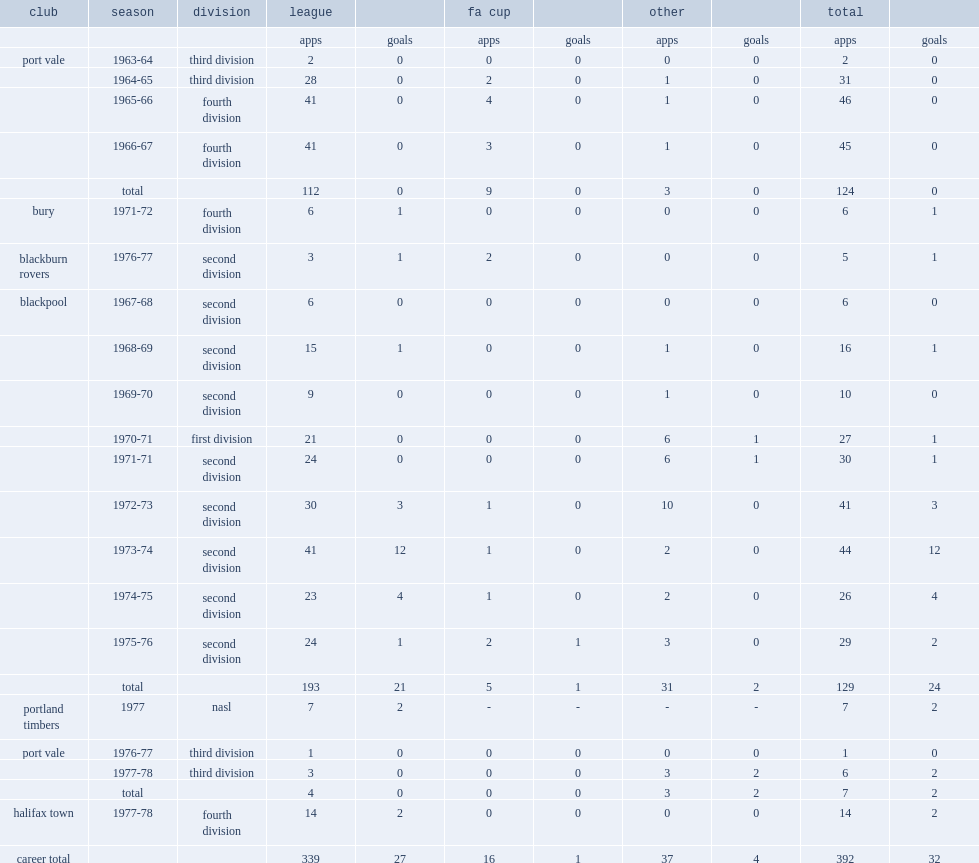How many games did terry alcock play in 1963-64, starting his career at third division club port vale in 1963? 2.0. 